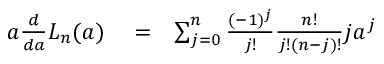<formula> <loc_0><loc_0><loc_500><loc_500>\begin{array} { r l r } { a \frac { d } { d a } L _ { n } ( a ) } & = } & { \sum _ { j = 0 } ^ { n } \frac { ( - 1 ) ^ { j } } { j ! } \frac { n ! } { j ! ( n - j ) ! } j a ^ { j } } \end{array}</formula> 